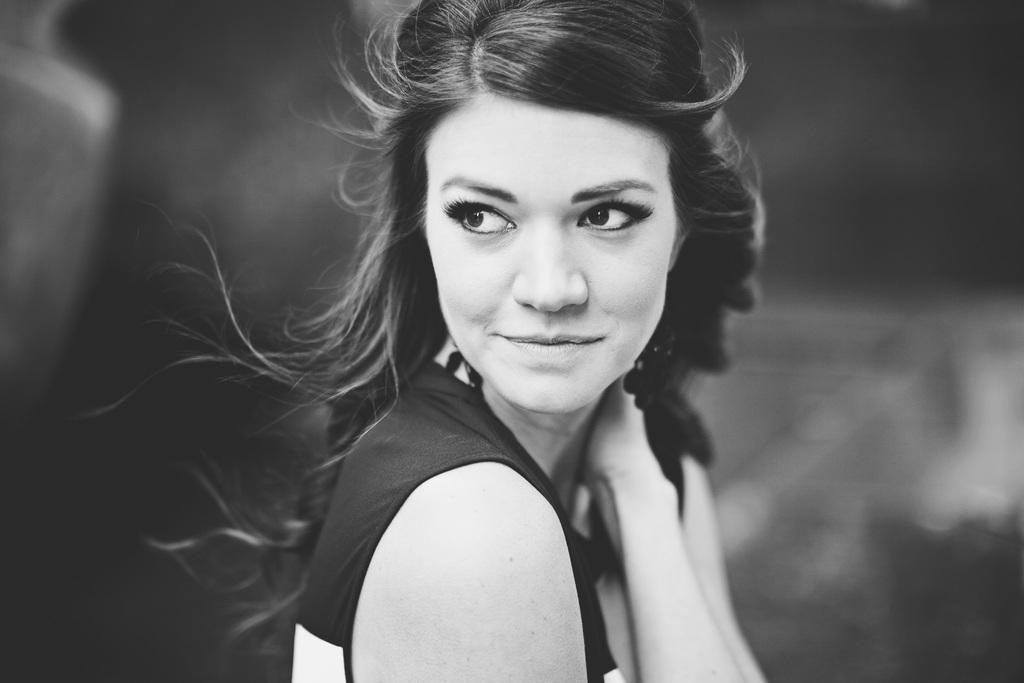Describe this image in one or two sentences. In this picture there is a woman. She is wearing t-shirt and she is smiling. In the back i can see the blur background. 